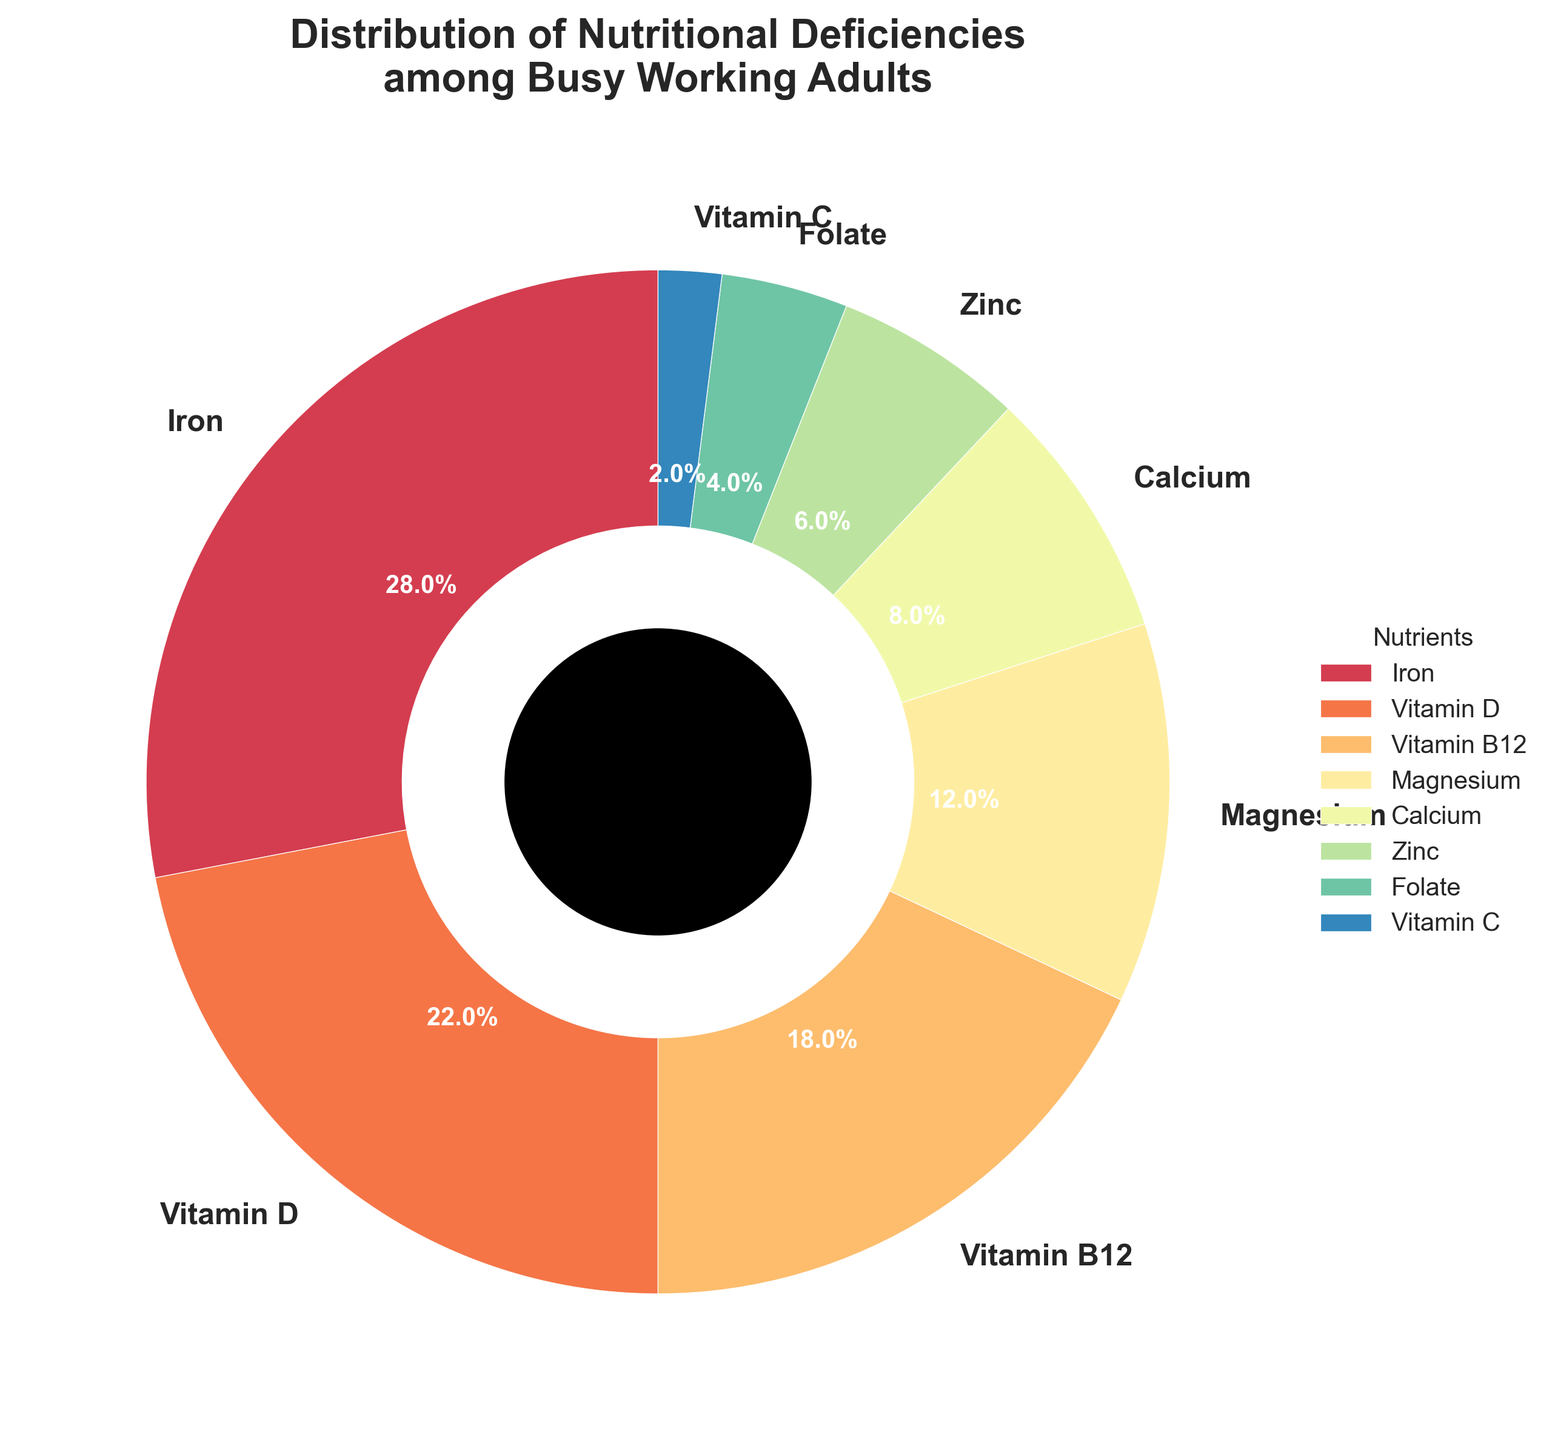Which nutrient deficiency has the highest percentage among busy working adults? By visually perceiving the largest slice in the pie chart, the Iron deficiency shows the largest percentage slice.
Answer: Iron Which two nutrients combined constitute less than 10% of the total deficiencies? Observe the smaller slices in the pie chart and identify their percentages. Folate (4%) and Vitamin C (2%) together sum to 6%, which is less than 10%.
Answer: Folate and Vitamin C How does the percentage of Vitamin B12 deficiency compare to Vitamin D deficiency? Compare the sizes of the slices labeled Vitamin B12 and Vitamin D. Vitamin D is 22%, which is larger than Vitamin B12's 18%.
Answer: Vitamin D deficiency is higher What is the total percentage of Iron, Vitamin D, and Vitamin B12 deficiencies combined? Sum the percentages of Iron (28%), Vitamin D (22%), and Vitamin B12 (18%). The result is 28 + 22 + 18 = 68%.
Answer: 68% Which nutrient deficiency is represented by the smallest slice in the pie chart? Find the slice with the smallest size on the chart. Vitamin C has the smallest percentage at 2%.
Answer: Vitamin C How does the percentage of Calcium deficiency compare to that of Magnesium deficiency? Compare the sizes of the slices labeled Calcium and Magnesium. Calcium is 8%, which is less than Magnesium's 12%.
Answer: Magnesium deficiency is higher What is the combined percentage of Zinc, Folate, and Vitamin C deficiencies? Sum the percentages of Zinc (6%), Folate (4%), and Vitamin C (2%). The result is 6 + 4 + 2 = 12%.
Answer: 12% What percentage of the total deficiencies is due to Vitamin D and Calcium combined? Sum the percentages of Vitamin D (22%) and Calcium (8%). The result is 22 + 8 = 30%.
Answer: 30% Is the sum of Iron and Zinc deficiencies greater than the sum of Magnesium and Calcium deficiencies? Calculate the sums: Iron (28%) + Zinc (6%) = 34%, and Magnesium (12%) + Calcium (8%) = 20%. Compare these results; 34% is greater than 20%.
Answer: Yes Which nutrient deficiency percentage is exactly half of Iron deficiency? Identify half of Iron deficiency, which is 28% / 2 = 14%. Check the chart for this value. None of the components exactly match 14%.
Answer: None 